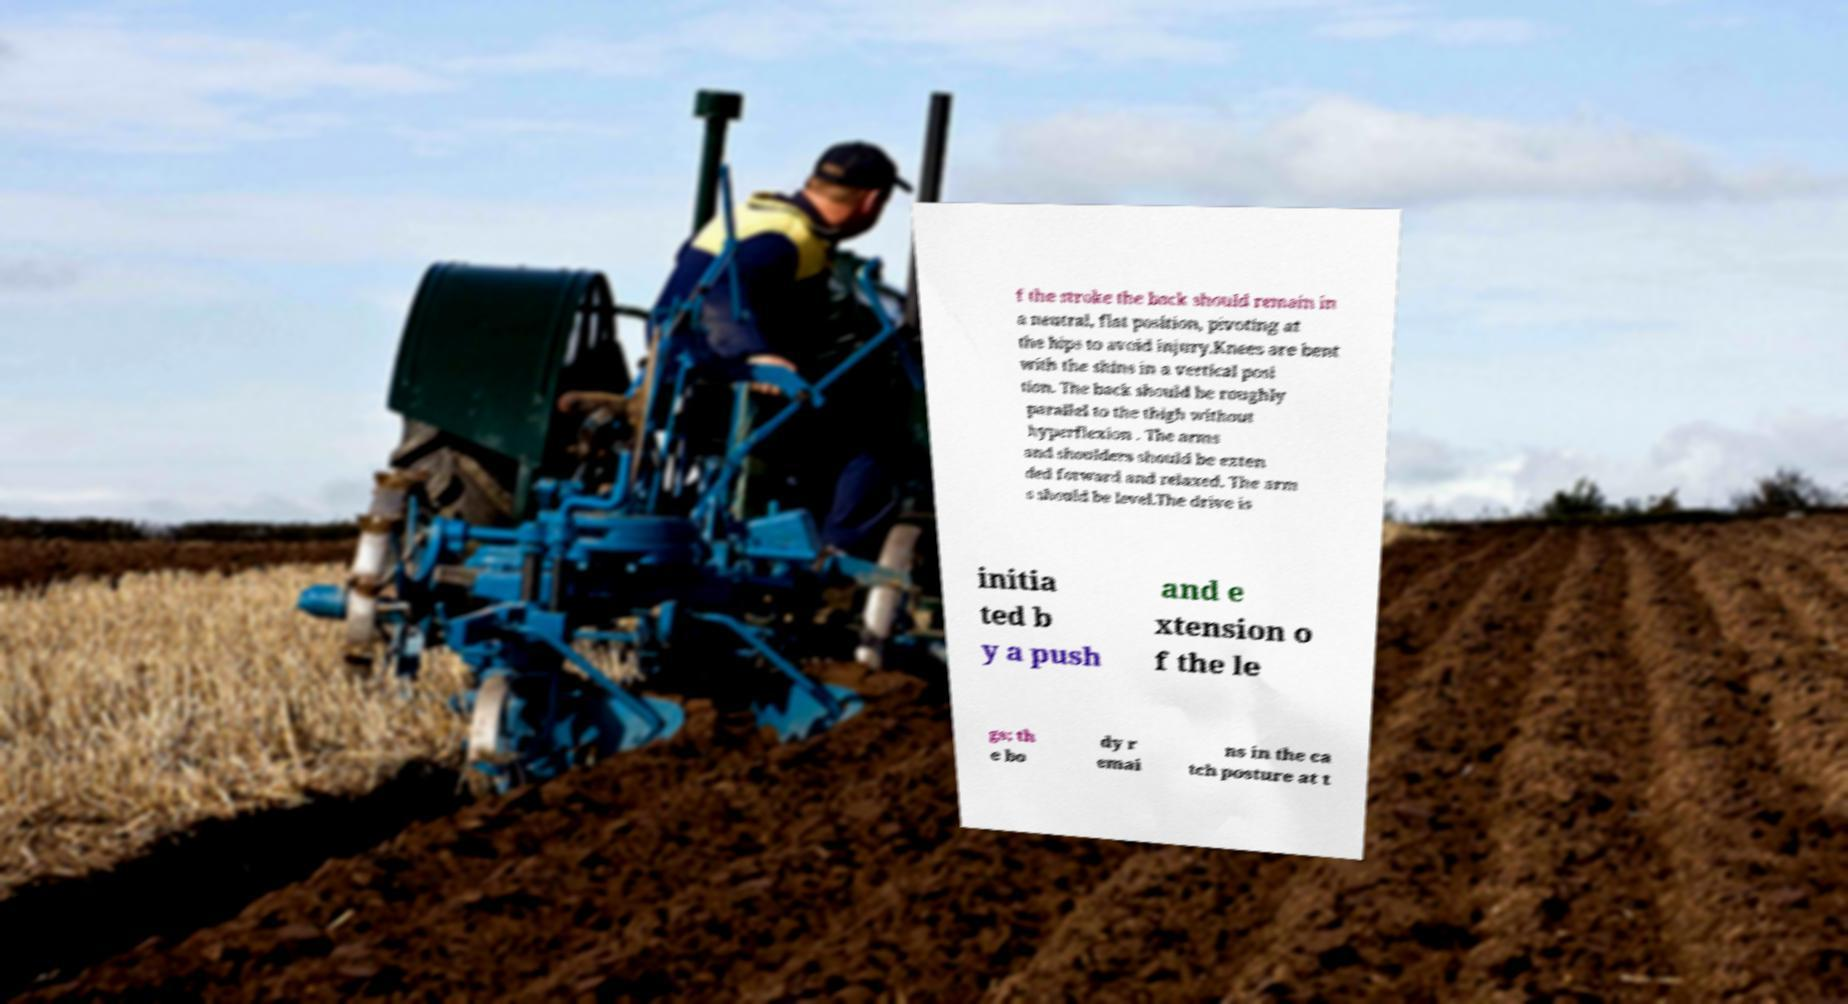Can you read and provide the text displayed in the image?This photo seems to have some interesting text. Can you extract and type it out for me? f the stroke the back should remain in a neutral, flat position, pivoting at the hips to avoid injury.Knees are bent with the shins in a vertical posi tion. The back should be roughly parallel to the thigh without hyperflexion . The arms and shoulders should be exten ded forward and relaxed. The arm s should be level.The drive is initia ted b y a push and e xtension o f the le gs; th e bo dy r emai ns in the ca tch posture at t 